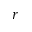<formula> <loc_0><loc_0><loc_500><loc_500>r</formula> 